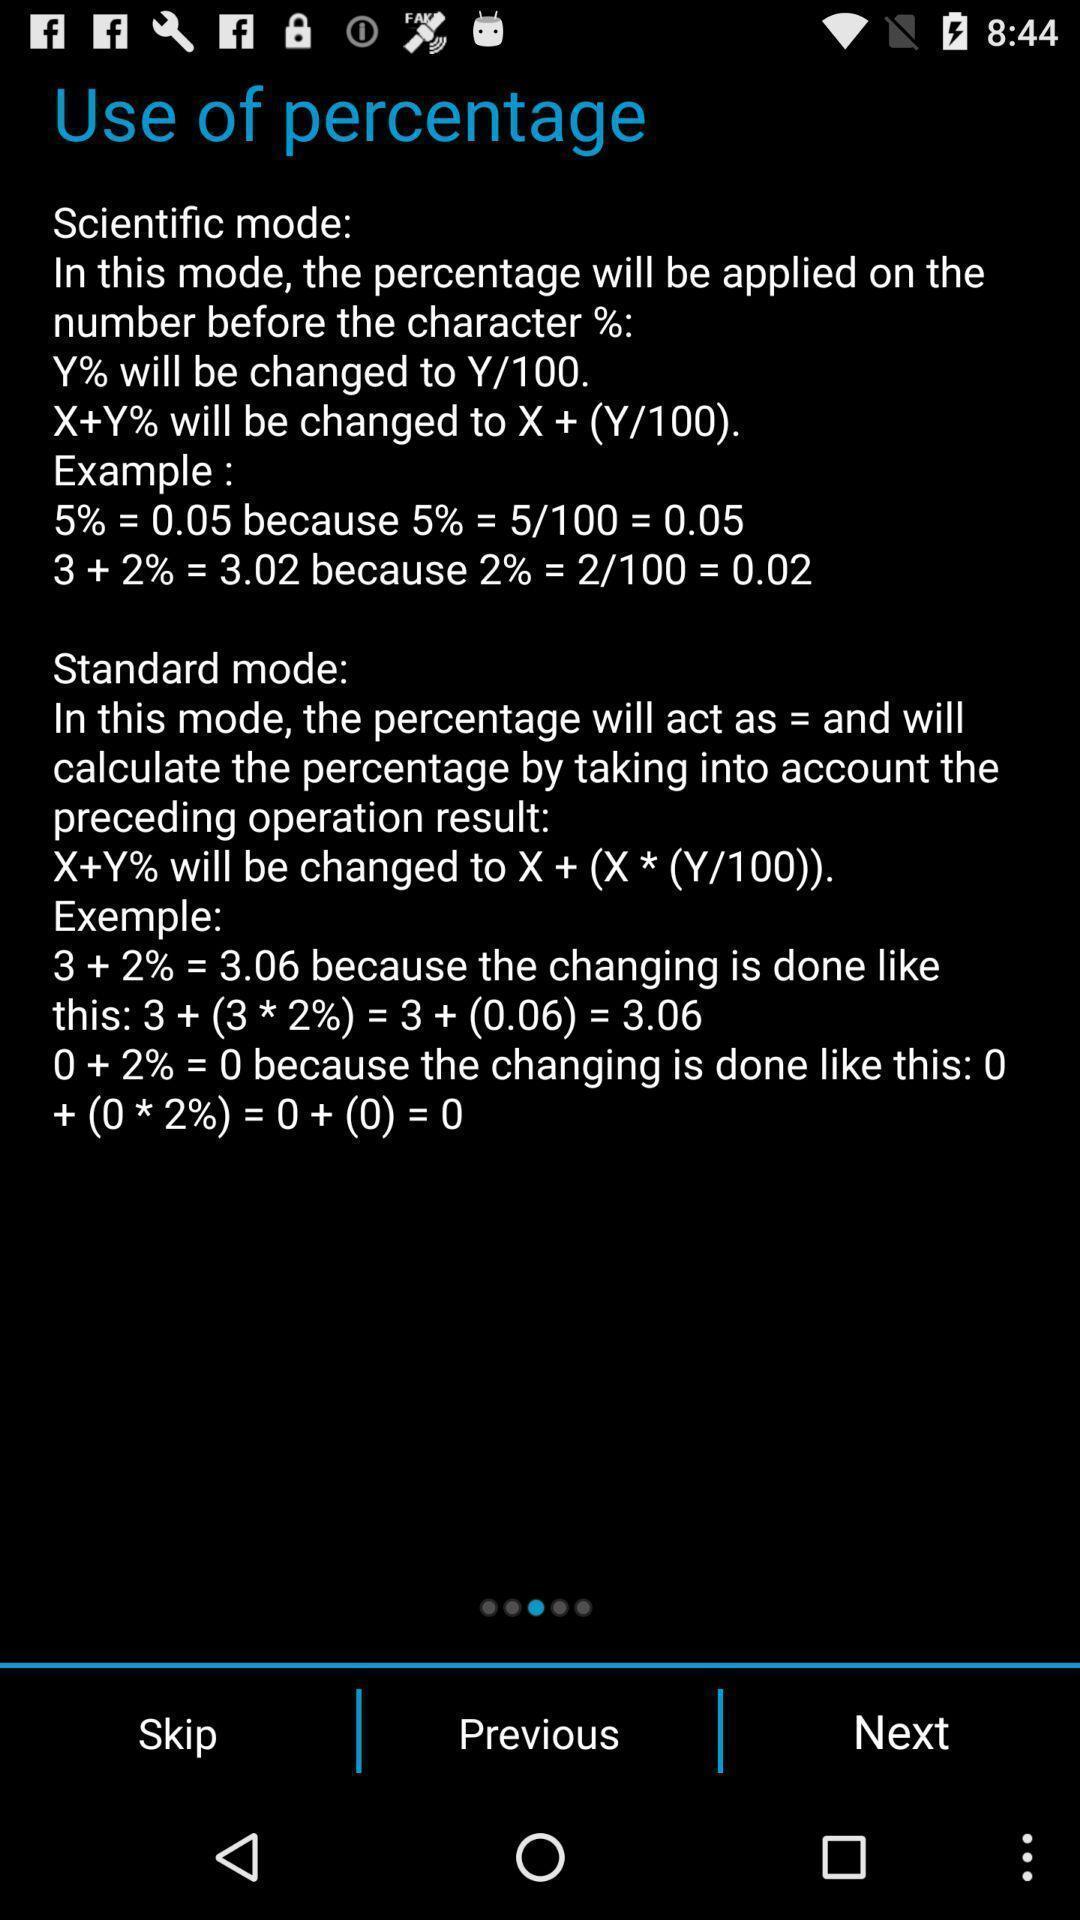Tell me about the visual elements in this screen capture. Use of percentage page in a maths app. 